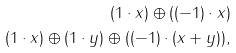<formula> <loc_0><loc_0><loc_500><loc_500>( 1 \cdot x ) \oplus ( ( - 1 ) \cdot x ) \\ ( 1 \cdot x ) \oplus ( 1 \cdot y ) \oplus ( ( - 1 ) \cdot ( x + y ) ) ,</formula> 